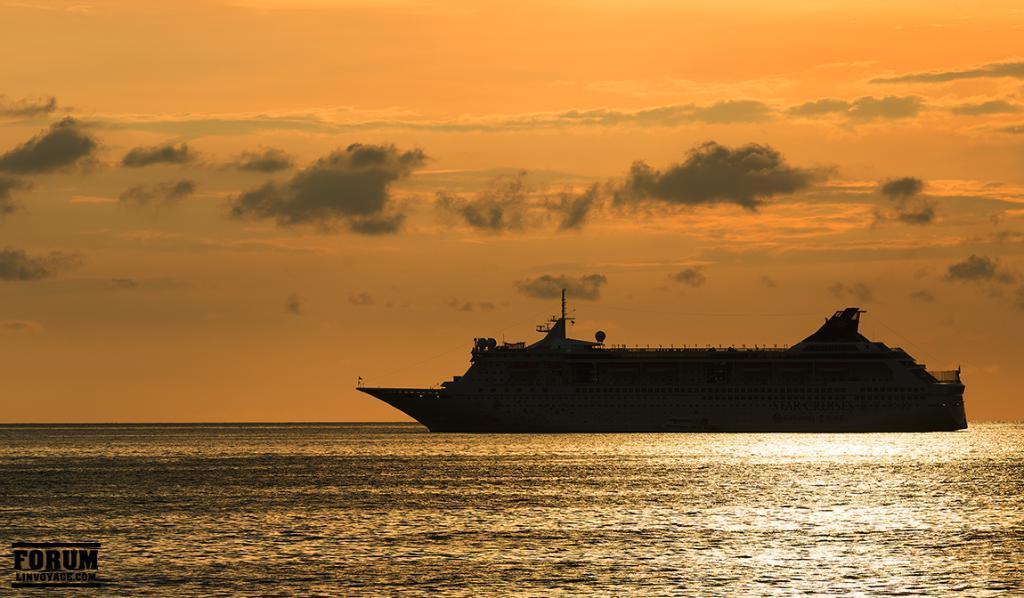In one or two sentences, can you explain what this image depicts? This image consists of a ship moving on the water. At the bottom, there is water. At the top, there are clouds in the sky. 